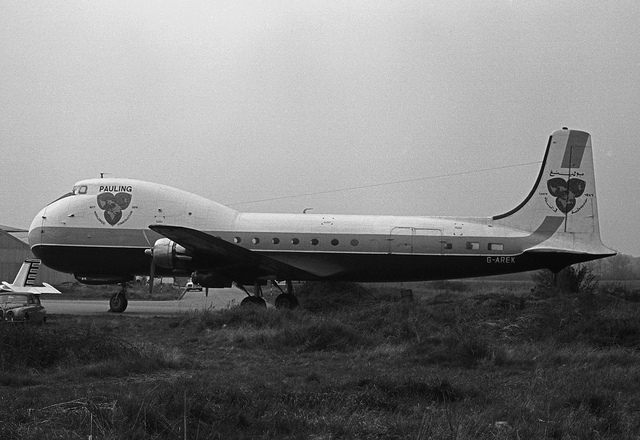Identify the text contained in this image. PAULING G-AREX 